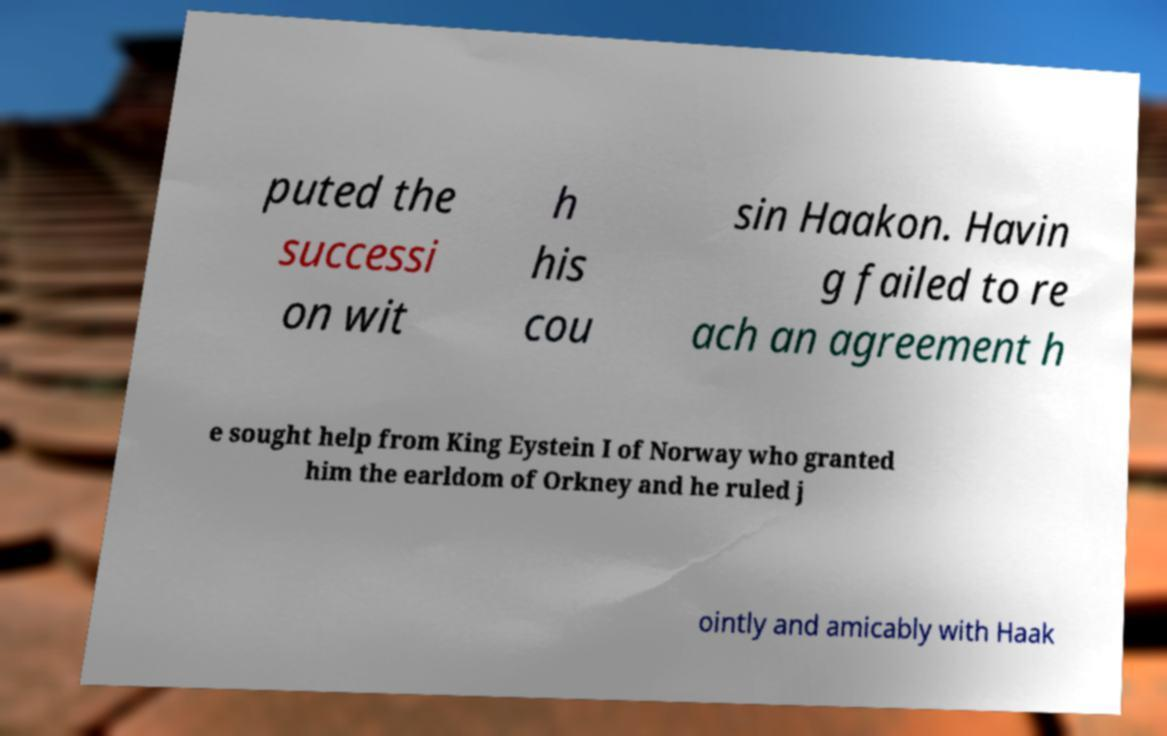Can you accurately transcribe the text from the provided image for me? puted the successi on wit h his cou sin Haakon. Havin g failed to re ach an agreement h e sought help from King Eystein I of Norway who granted him the earldom of Orkney and he ruled j ointly and amicably with Haak 